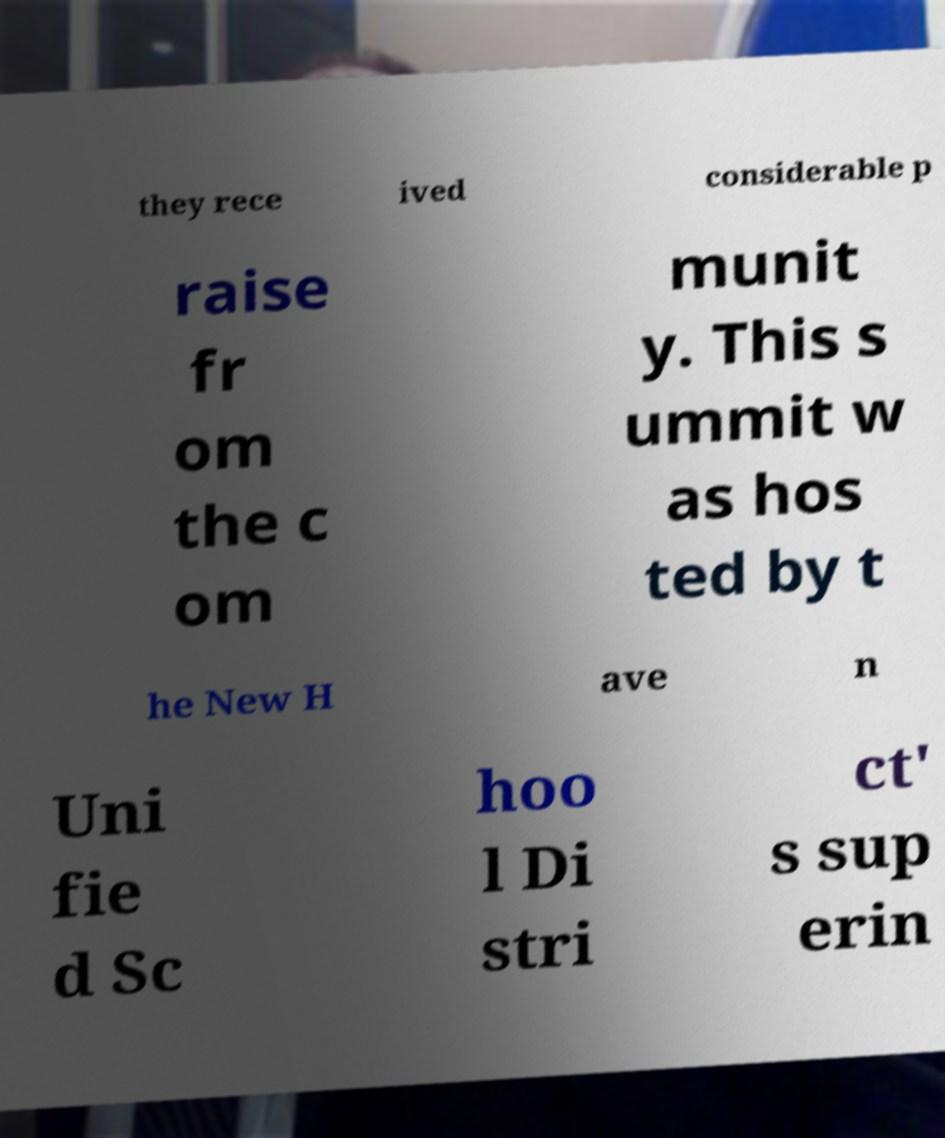Can you read and provide the text displayed in the image?This photo seems to have some interesting text. Can you extract and type it out for me? they rece ived considerable p raise fr om the c om munit y. This s ummit w as hos ted by t he New H ave n Uni fie d Sc hoo l Di stri ct' s sup erin 